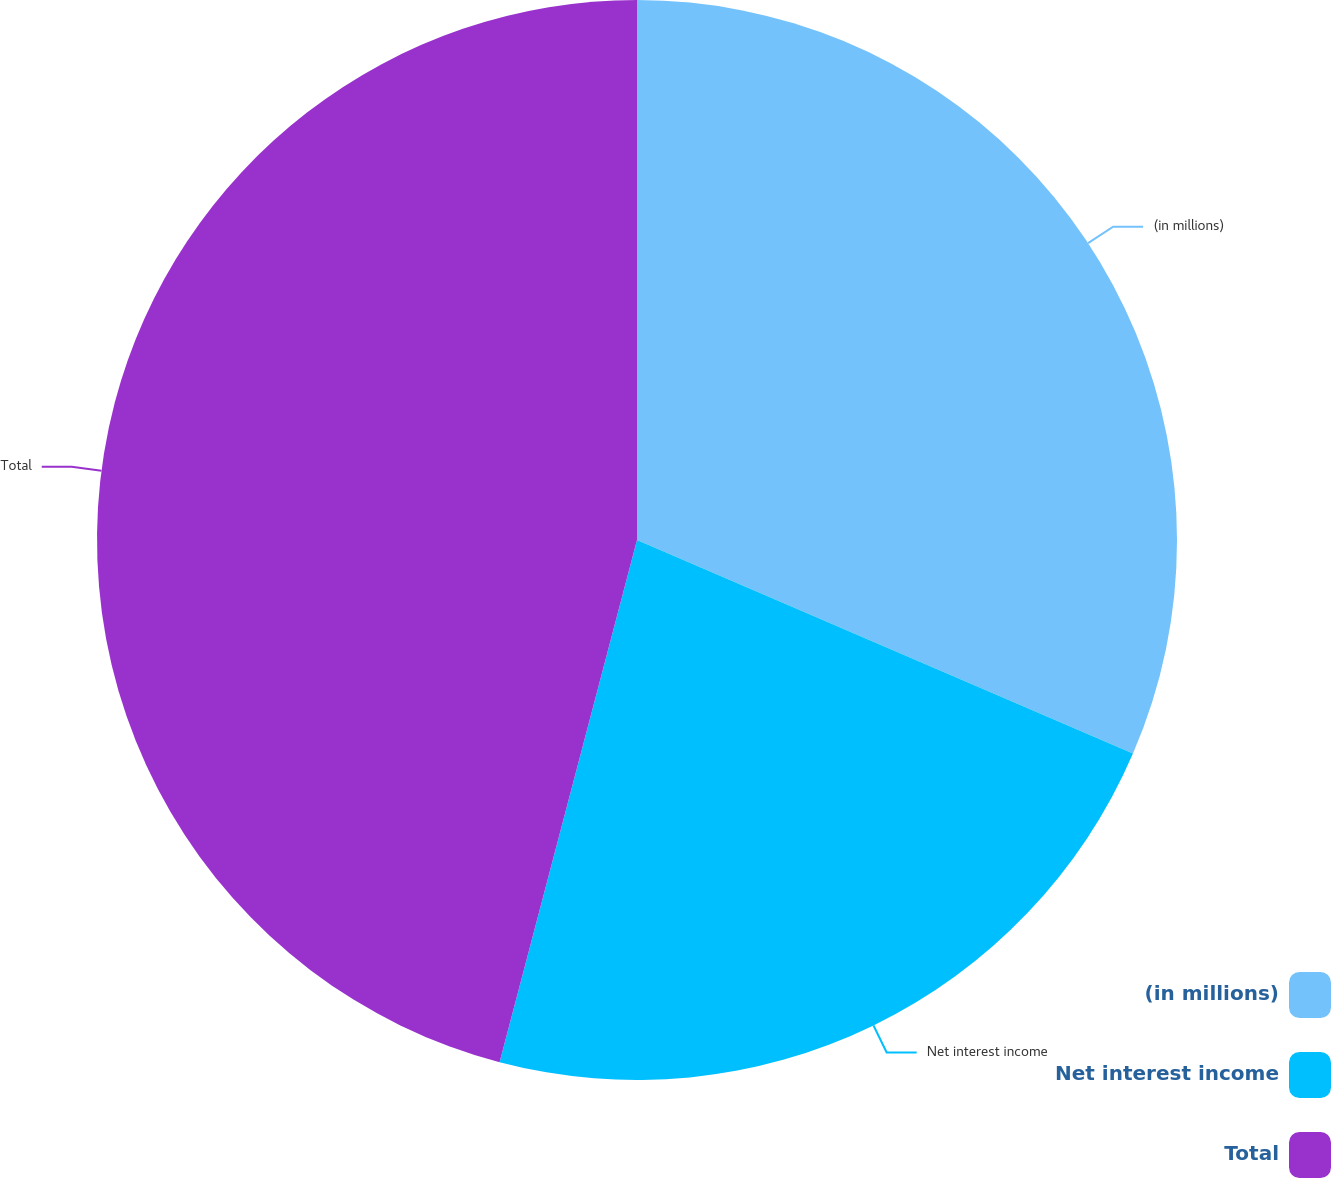<chart> <loc_0><loc_0><loc_500><loc_500><pie_chart><fcel>(in millions)<fcel>Net interest income<fcel>Total<nl><fcel>31.47%<fcel>22.62%<fcel>45.9%<nl></chart> 